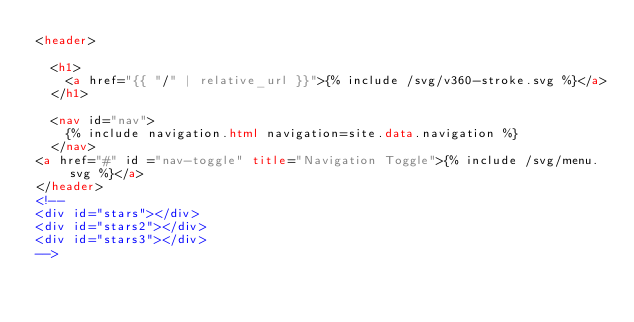Convert code to text. <code><loc_0><loc_0><loc_500><loc_500><_HTML_><header>

  <h1>
    <a href="{{ "/" | relative_url }}">{% include /svg/v360-stroke.svg %}</a>
  </h1>

  <nav id="nav">
    {% include navigation.html navigation=site.data.navigation %}
  </nav>
<a href="#" id ="nav-toggle" title="Navigation Toggle">{% include /svg/menu.svg %}</a>
</header>
<!--
<div id="stars"></div>
<div id="stars2"></div>
<div id="stars3"></div>
--></code> 